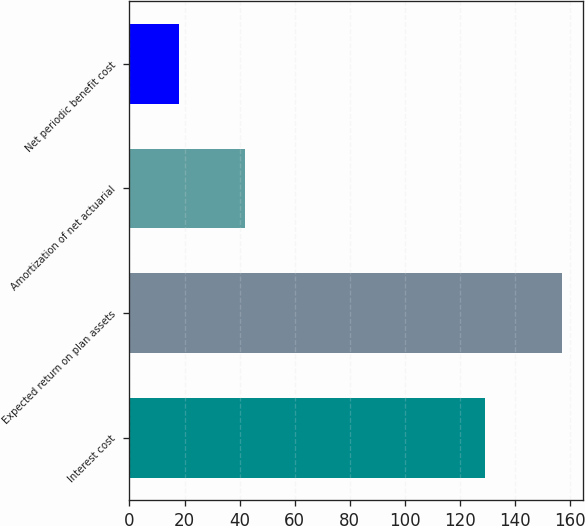Convert chart. <chart><loc_0><loc_0><loc_500><loc_500><bar_chart><fcel>Interest cost<fcel>Expected return on plan assets<fcel>Amortization of net actuarial<fcel>Net periodic benefit cost<nl><fcel>129<fcel>157<fcel>42<fcel>18<nl></chart> 